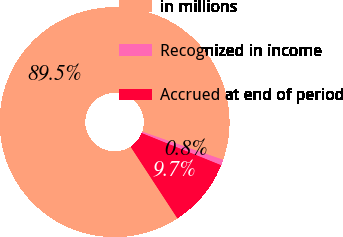Convert chart. <chart><loc_0><loc_0><loc_500><loc_500><pie_chart><fcel>in millions<fcel>Recognized in income<fcel>Accrued at end of period<nl><fcel>89.53%<fcel>0.8%<fcel>9.67%<nl></chart> 